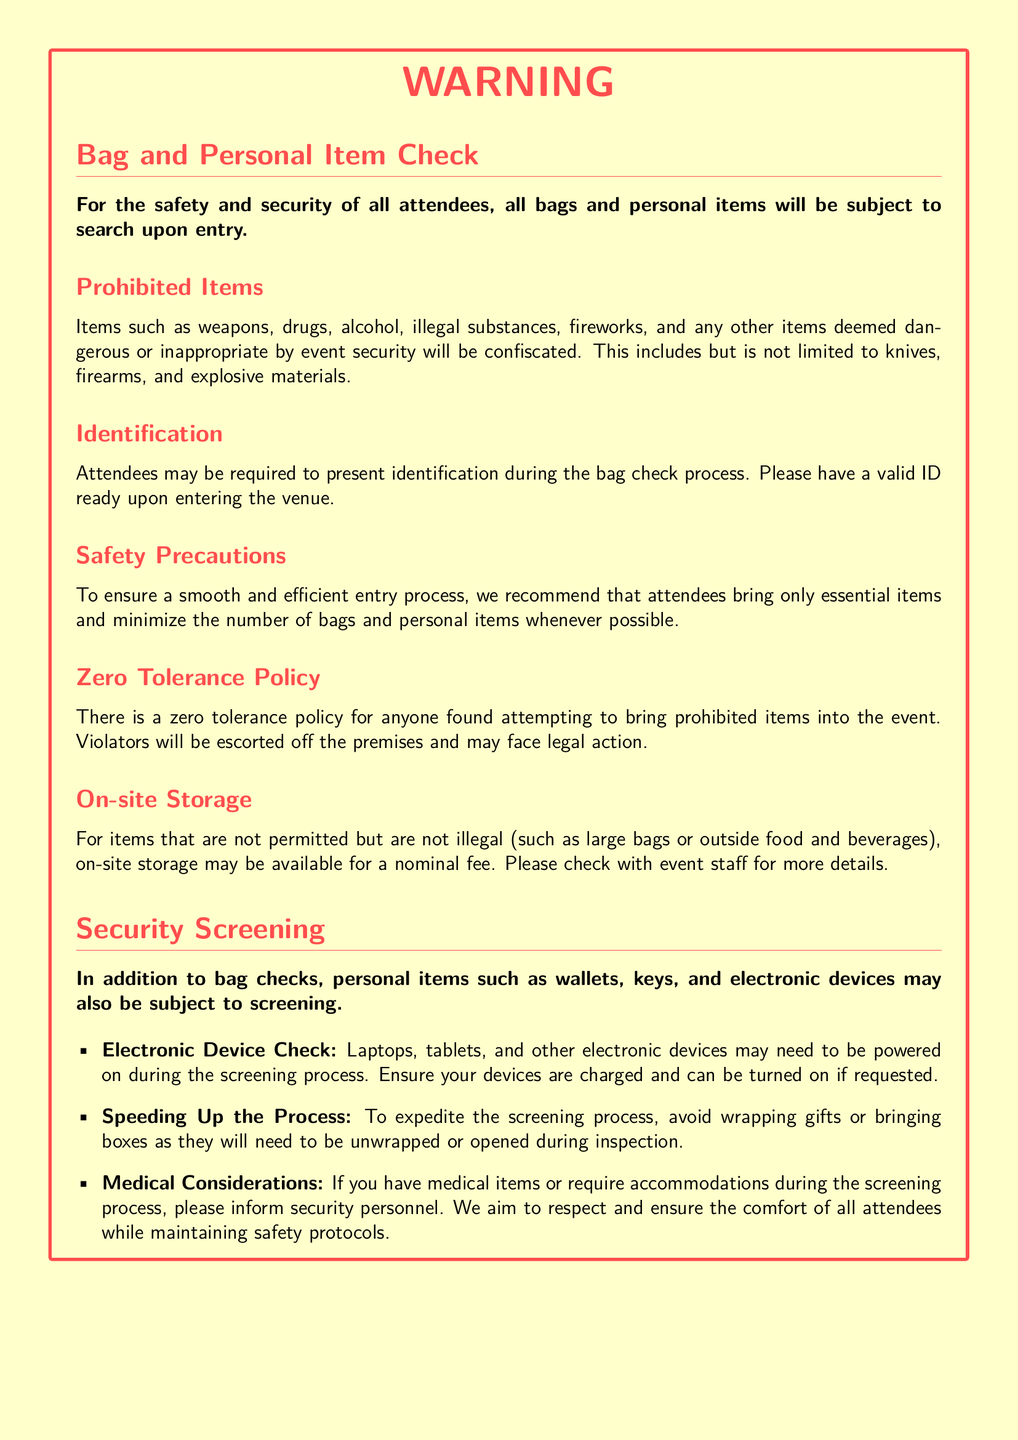What items are subject to search upon entry? All bags and personal items are subject to search upon entry as stated in the document.
Answer: All bags and personal items What is the zero tolerance policy about? The document explains that there is a zero tolerance policy for prohibited items, detailing actions against violators.
Answer: Prohibited items What must attendees present during the bag check process? The document specifies that attendees may be required to present identification during the bag check process.
Answer: Identification What types of items may be confiscated? The warning label lists several items that fall under the category of confiscated items, which include weapons and illegal substances.
Answer: Weapons, drugs, alcohol What should attendees do to expedite the screening process? The document advises attendees to avoid wrapping gifts or bringing boxes to speed up the screening process.
Answer: Avoid wrapping gifts What may be available for larger prohibited items? The document mentions that on-site storage may be available for items that are not permitted but not illegal.
Answer: On-site storage How will electronic devices be treated during screening? According to the warning label, laptops, tablets, and other electronic devices may need to be powered on during screening.
Answer: Powered on What should attendees do if they have medical items? The document suggests that attendees with medical items should inform security personnel during the screening process.
Answer: Inform security personnel 